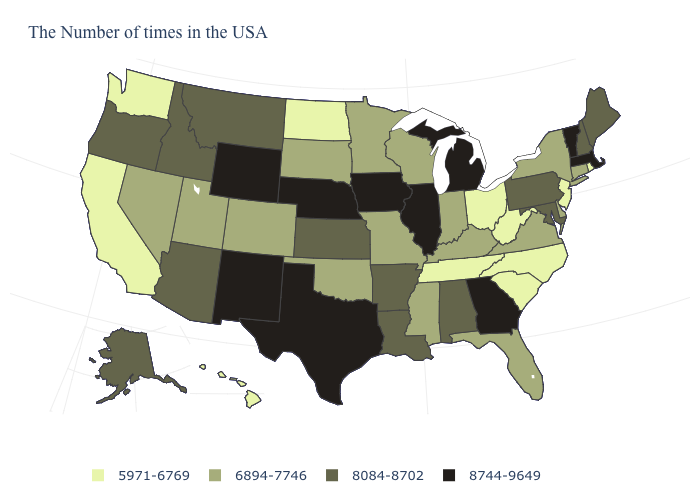Name the states that have a value in the range 8744-9649?
Answer briefly. Massachusetts, Vermont, Georgia, Michigan, Illinois, Iowa, Nebraska, Texas, Wyoming, New Mexico. What is the value of Idaho?
Short answer required. 8084-8702. What is the value of South Dakota?
Write a very short answer. 6894-7746. Does California have a lower value than Alaska?
Keep it brief. Yes. What is the lowest value in the MidWest?
Be succinct. 5971-6769. How many symbols are there in the legend?
Quick response, please. 4. Is the legend a continuous bar?
Concise answer only. No. Is the legend a continuous bar?
Keep it brief. No. Name the states that have a value in the range 8084-8702?
Quick response, please. Maine, New Hampshire, Maryland, Pennsylvania, Alabama, Louisiana, Arkansas, Kansas, Montana, Arizona, Idaho, Oregon, Alaska. Name the states that have a value in the range 8084-8702?
Write a very short answer. Maine, New Hampshire, Maryland, Pennsylvania, Alabama, Louisiana, Arkansas, Kansas, Montana, Arizona, Idaho, Oregon, Alaska. Name the states that have a value in the range 8744-9649?
Give a very brief answer. Massachusetts, Vermont, Georgia, Michigan, Illinois, Iowa, Nebraska, Texas, Wyoming, New Mexico. What is the value of Missouri?
Give a very brief answer. 6894-7746. Does Arizona have the same value as Oregon?
Answer briefly. Yes. What is the lowest value in the USA?
Concise answer only. 5971-6769. Among the states that border Ohio , does West Virginia have the lowest value?
Write a very short answer. Yes. 